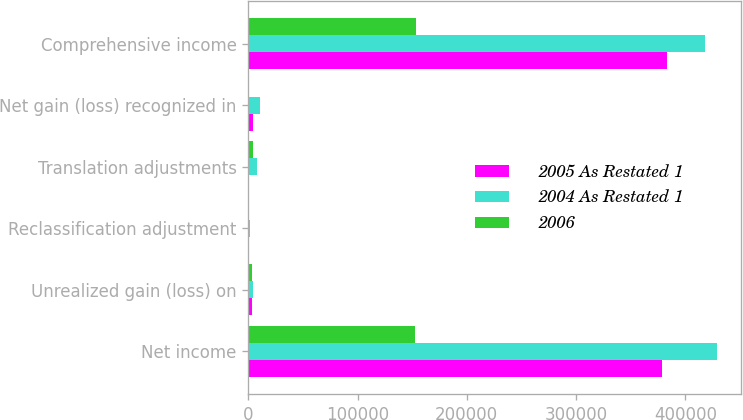Convert chart. <chart><loc_0><loc_0><loc_500><loc_500><stacked_bar_chart><ecel><fcel>Net income<fcel>Unrealized gain (loss) on<fcel>Reclassification adjustment<fcel>Translation adjustments<fcel>Net gain (loss) recognized in<fcel>Comprehensive income<nl><fcel>2005 As Restated 1<fcel>379015<fcel>3382<fcel>3<fcel>776<fcel>4155<fcel>383170<nl><fcel>2004 As Restated 1<fcel>428978<fcel>4573<fcel>1419<fcel>7988<fcel>11142<fcel>417836<nl><fcel>2006<fcel>152820<fcel>3462<fcel>51<fcel>4104<fcel>591<fcel>153411<nl></chart> 